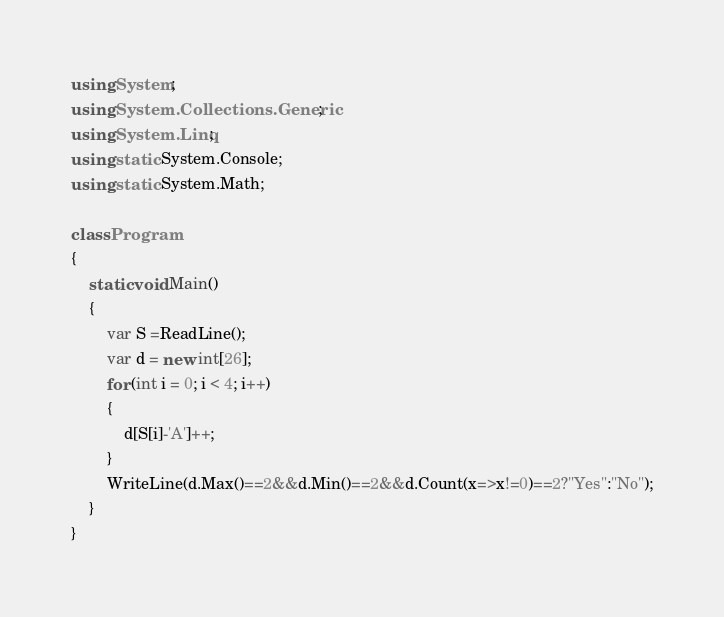<code> <loc_0><loc_0><loc_500><loc_500><_C#_>using System;
using System.Collections.Generic;
using System.Linq;
using static System.Console;
using static System.Math;

class Program
{
    static void Main()
    {
        var S =ReadLine();
        var d = new int[26];
        for (int i = 0; i < 4; i++)
        {
            d[S[i]-'A']++;
        }
        WriteLine(d.Max()==2&&d.Min()==2&&d.Count(x=>x!=0)==2?"Yes":"No");
    }
}
</code> 